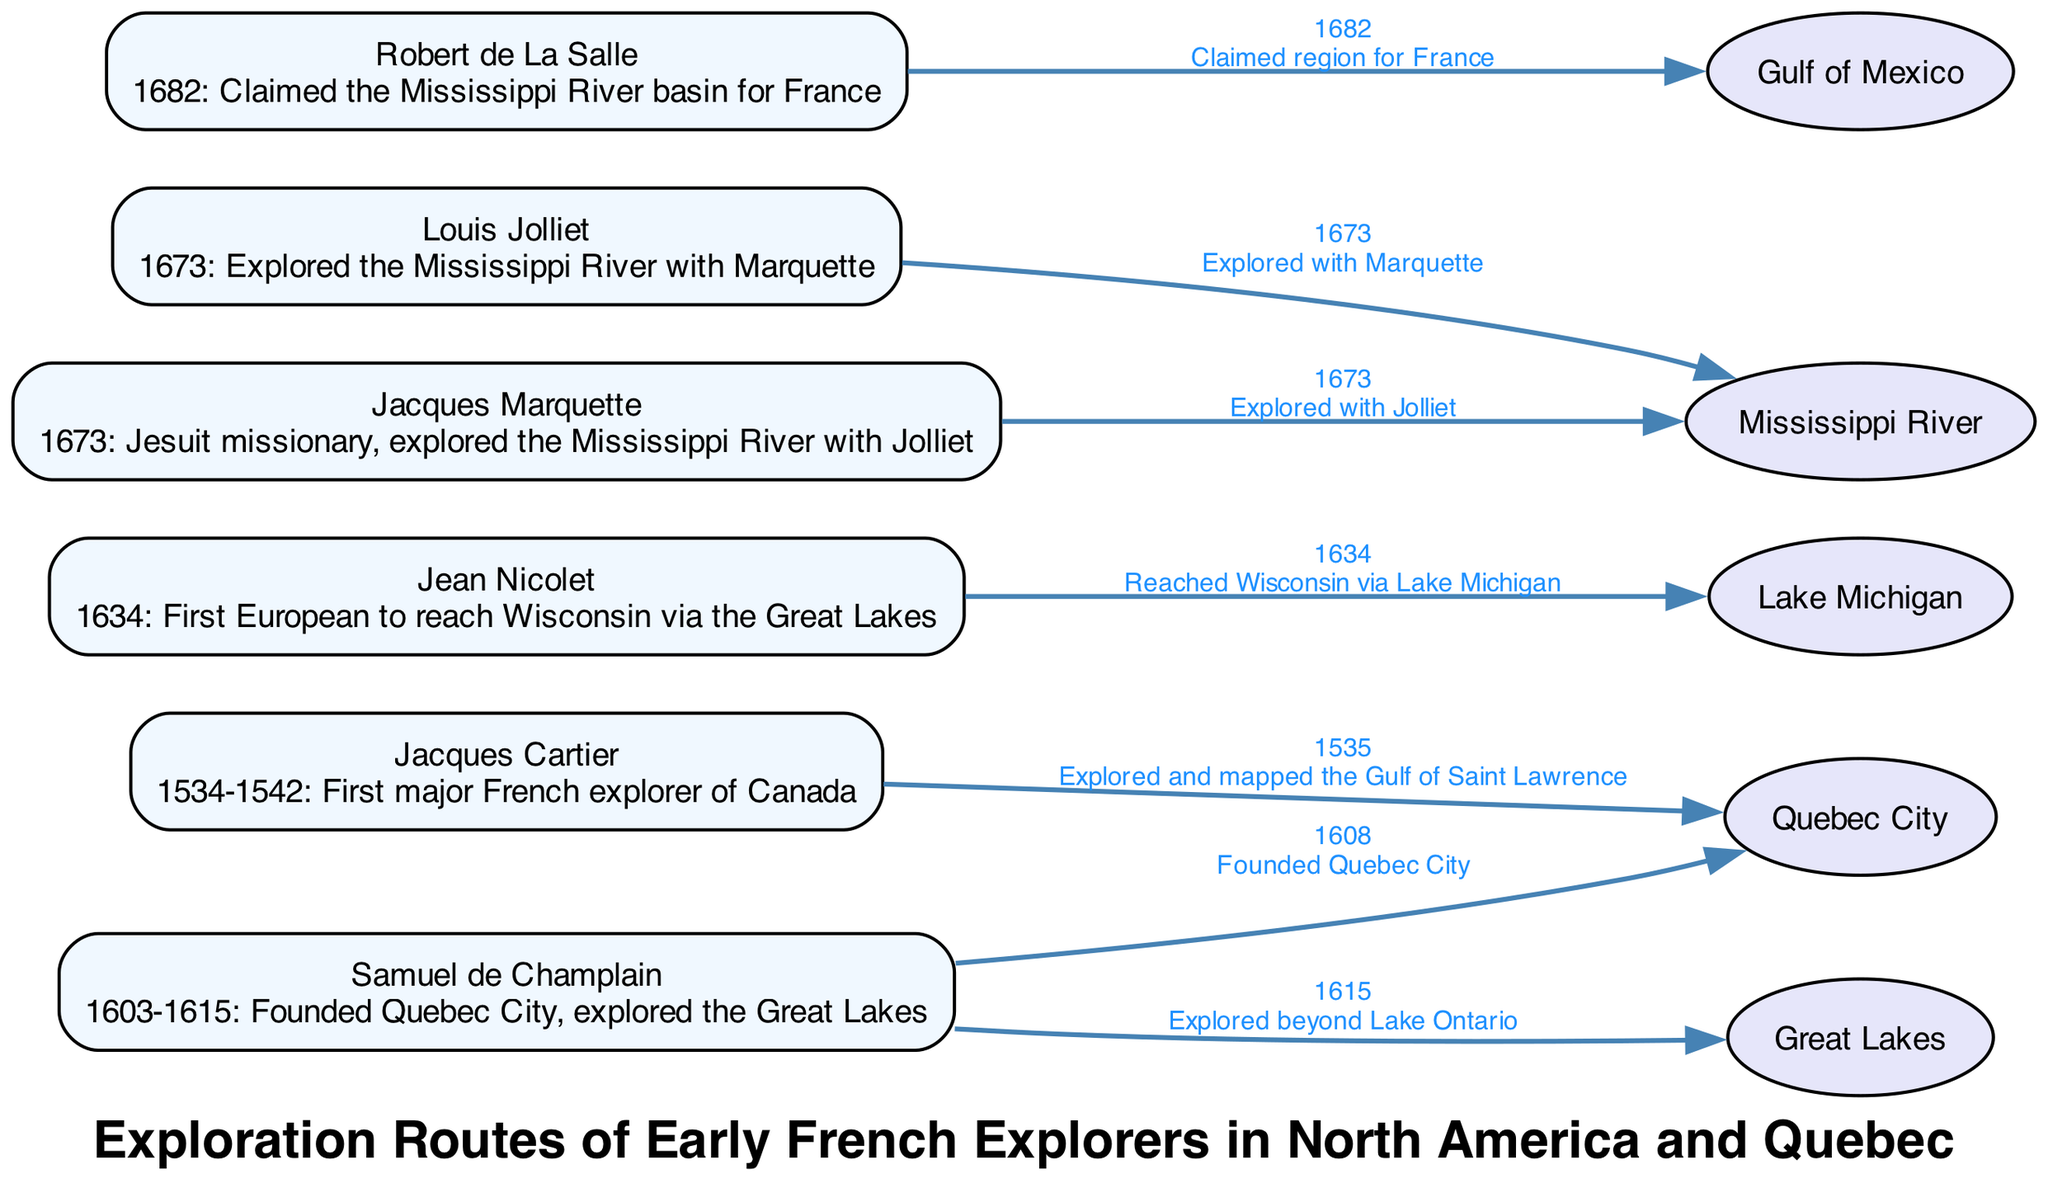What year did Jacques Cartier explore the Gulf of Saint Lawrence? The diagram shows an edge from Jacques Cartier to Quebec City with the label "1535". This indicates that in 1535, Cartier explored the Gulf of Saint Lawrence.
Answer: 1535 Which explorer founded Quebec City? The diagram indicates there is an edge from Samuel de Champlain to Quebec City with the label "1608". This means that Samuel de Champlain is credited with founding Quebec City in that year.
Answer: Samuel de Champlain How many explorers are depicted in the diagram? The diagram has six nodes representing explorers: Jacques Cartier, Samuel de Champlain, Jean Nicolet, Louis Jolliet, Jacques Marquette, and Robert de La Salle. Counting these nodes, we find there are six explorers in total.
Answer: 6 What body of water did Jean Nicolet reach? The diagram shows an edge from Jean Nicolet to Lake Michigan with the label "1634". This label and connection indicate that Nicolet reached Lake Michigan in 1634.
Answer: Lake Michigan Which explorer explored the Mississippi River along with Marquette? The diagram shows an edge from Louis Jolliet to the Mississippi River with the label "1673" and another edge from Jacques Marquette to the same river. Both explorers are depicted as having explored the Mississippi River together in that year.
Answer: Louis Jolliet and Jacques Marquette What was the year when Robert de La Salle claimed the Mississippi River basin for France? There is an edge from Robert de La Salle to the Gulf of Mexico with the label "1682". This indicates that in 1682, La Salle claimed the Mississippi River basin for France.
Answer: 1682 What geographical area did Samuel de Champlain explore in 1615? The diagram indicates an edge from Samuel de Champlain to the Great Lakes labeled "1615". This shows that Champlain explored the Great Lakes in that year.
Answer: Great Lakes 